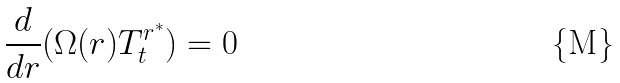Convert formula to latex. <formula><loc_0><loc_0><loc_500><loc_500>\frac { d } { d r } ( \Omega ( r ) T ^ { r ^ { \ast } } _ { t } ) = 0</formula> 